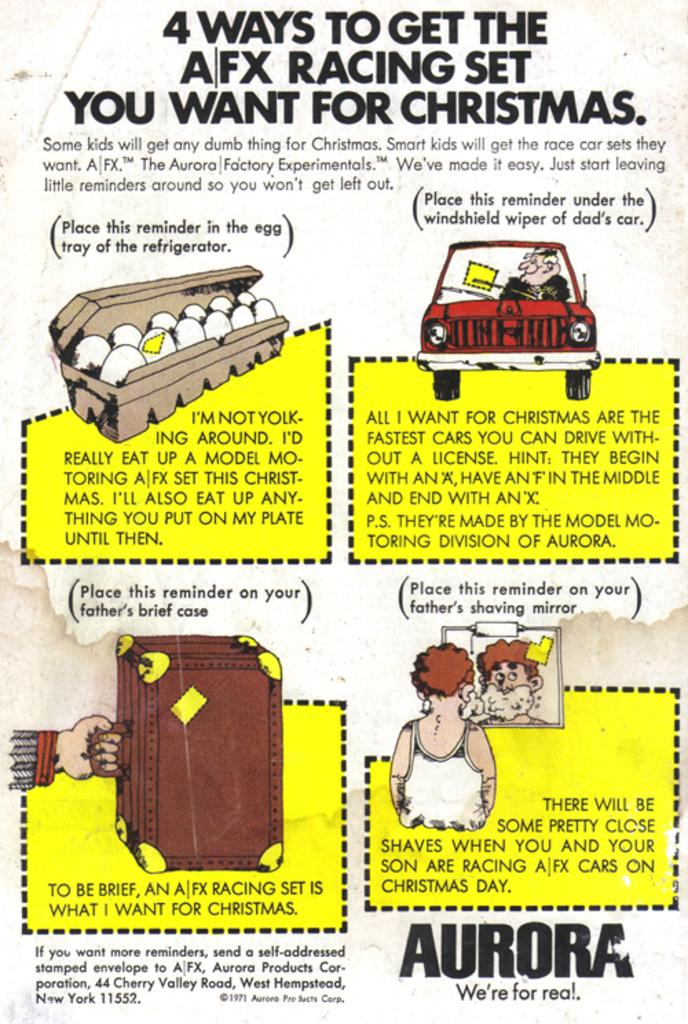What type of visual is the image? The image is a poster. What is the main subject of the poster? There is a vehicle depicted on the poster. Are there any people in the poster? Yes, there is a person depicted on the poster. What else can be seen on the poster besides the vehicle and person? There are objects present on the poster. Is there any text on the poster? Yes, there is text on the poster. Can you see a quill being used by the person on the poster? There is no quill present in the image, and the person is not using one. Is there a balloon floating in the background of the poster? There is no balloon present in the image. 